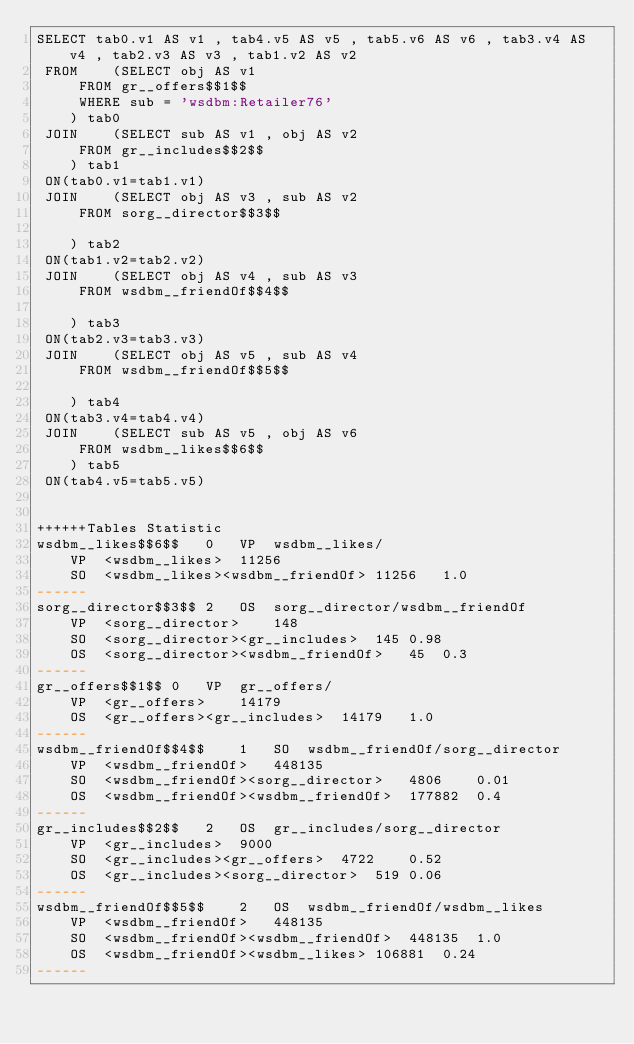Convert code to text. <code><loc_0><loc_0><loc_500><loc_500><_SQL_>SELECT tab0.v1 AS v1 , tab4.v5 AS v5 , tab5.v6 AS v6 , tab3.v4 AS v4 , tab2.v3 AS v3 , tab1.v2 AS v2 
 FROM    (SELECT obj AS v1 
	 FROM gr__offers$$1$$ 
	 WHERE sub = 'wsdbm:Retailer76'
	) tab0
 JOIN    (SELECT sub AS v1 , obj AS v2 
	 FROM gr__includes$$2$$
	) tab1
 ON(tab0.v1=tab1.v1)
 JOIN    (SELECT obj AS v3 , sub AS v2 
	 FROM sorg__director$$3$$
	
	) tab2
 ON(tab1.v2=tab2.v2)
 JOIN    (SELECT obj AS v4 , sub AS v3 
	 FROM wsdbm__friendOf$$4$$
	
	) tab3
 ON(tab2.v3=tab3.v3)
 JOIN    (SELECT obj AS v5 , sub AS v4 
	 FROM wsdbm__friendOf$$5$$
	
	) tab4
 ON(tab3.v4=tab4.v4)
 JOIN    (SELECT sub AS v5 , obj AS v6 
	 FROM wsdbm__likes$$6$$
	) tab5
 ON(tab4.v5=tab5.v5)


++++++Tables Statistic
wsdbm__likes$$6$$	0	VP	wsdbm__likes/
	VP	<wsdbm__likes>	11256
	SO	<wsdbm__likes><wsdbm__friendOf>	11256	1.0
------
sorg__director$$3$$	2	OS	sorg__director/wsdbm__friendOf
	VP	<sorg__director>	148
	SO	<sorg__director><gr__includes>	145	0.98
	OS	<sorg__director><wsdbm__friendOf>	45	0.3
------
gr__offers$$1$$	0	VP	gr__offers/
	VP	<gr__offers>	14179
	OS	<gr__offers><gr__includes>	14179	1.0
------
wsdbm__friendOf$$4$$	1	SO	wsdbm__friendOf/sorg__director
	VP	<wsdbm__friendOf>	448135
	SO	<wsdbm__friendOf><sorg__director>	4806	0.01
	OS	<wsdbm__friendOf><wsdbm__friendOf>	177882	0.4
------
gr__includes$$2$$	2	OS	gr__includes/sorg__director
	VP	<gr__includes>	9000
	SO	<gr__includes><gr__offers>	4722	0.52
	OS	<gr__includes><sorg__director>	519	0.06
------
wsdbm__friendOf$$5$$	2	OS	wsdbm__friendOf/wsdbm__likes
	VP	<wsdbm__friendOf>	448135
	SO	<wsdbm__friendOf><wsdbm__friendOf>	448135	1.0
	OS	<wsdbm__friendOf><wsdbm__likes>	106881	0.24
------
</code> 